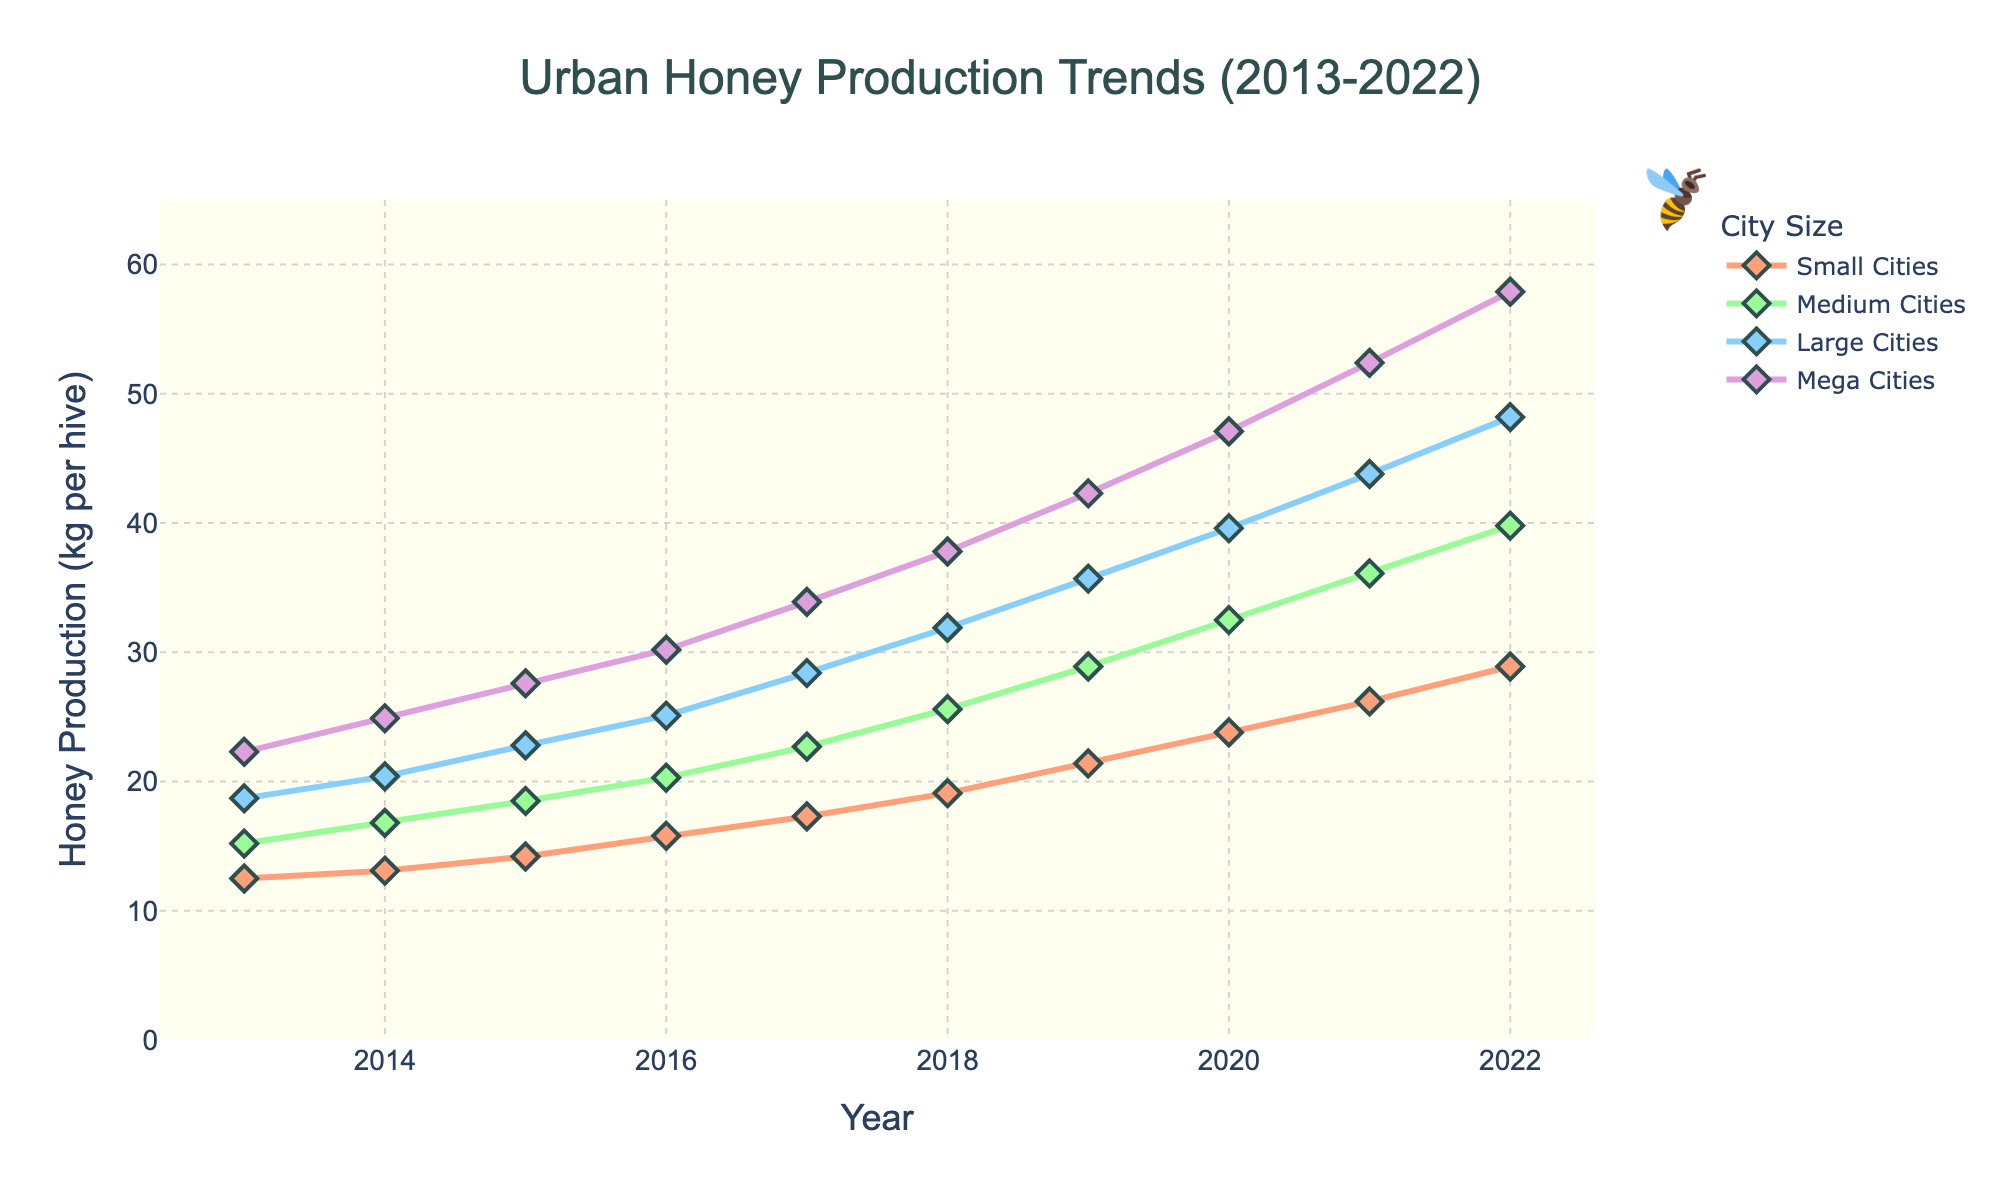What year saw the largest increase in honey production for Mega Cities? To determine this, we need to calculate the annual difference in honey production for Mega Cities and find the year with the largest difference. Calculating the differences year by year: 24.9 - 22.3 = 2.6, 27.6 - 24.9 = 2.7, 30.2 - 27.6 = 2.6, 33.9 - 30.2 = 3.7, 37.8 - 33.9 = 3.9, 42.3 - 37.8 = 4.5, 47.1 - 42.3 = 4.8, 52.4 - 47.1 = 5.3, 57.9 - 52.4 = 5.5. The largest increase of 5.5 occurred between 2021 and 2022.
Answer: 2021-2022 Which city size had the highest honey production in 2018? To answer this, we look for the highest value in the 2018 row: Small Cities (19.1), Medium Cities (25.6), Large Cities (31.9), Mega Cities (37.8). Mega Cities had the highest production with 37.8 kg per hive.
Answer: Mega Cities How did the honey production in Small Cities in 2016 compare to that in Large Cities in the same year? To compare, we extract the 2016 data: Small Cities (15.8), Large Cities (25.1). Large Cities had 25.1 - 15.8 = 9.3 kg per hive more production than Small Cities.
Answer: 9.3 kg more What was the average honey production in Medium Cities over the decade? To find the average, sum the yearly production for Medium Cities then divide by the number of years: (15.2 + 16.8 + 18.5 + 20.3 + 22.7 + 25.6 + 28.9 + 32.5 + 36.1 + 39.8) = 256.4, divide by 10, so the average is 25.64 kg per hive.
Answer: 25.64 kg per hive In 2022, which city size had the least honey production, and how much was it? Find the smallest value in the 2022 column: Small Cities (28.9), Medium Cities (39.8), Large Cities (48.2), Mega Cities (57.9). The least was Small Cities with 28.9 kg per hive.
Answer: Small Cities, 28.9 kg per hive By how much did honey production in Large Cities increase from 2019 to 2021? Subtract the 2019 value from the 2021 value for Large Cities: 43.8 - 35.7 = 8.1 kg per hive increase.
Answer: 8.1 kg per hive Which city size showed the steadiest growth pattern over the decade, and what suggests this? To determine the steadiest growth pattern, we observe the lineplots: Small Cities, Medium Cities, Large Cities, and Mega Cities. Mega Cities showed the steadiest growth since the production increased consistently each year, as evidenced by the smoothest and steepest rising line among the categories.
Answer: Mega Cities When did Medium Cities first surpass 30 kg per hive in honey production? Check the data for Medium Cities year by year: it first surpasses 30 kg per hive in the year 2020 with 32.5 kg per hive.
Answer: 2020 